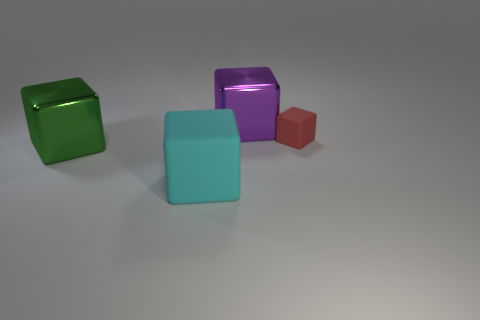Is there anything else that has the same size as the red object?
Your answer should be very brief. No. There is a metal cube that is in front of the red rubber object; is it the same size as the purple metal block?
Your answer should be very brief. Yes. There is a shiny thing behind the big metallic block that is in front of the red object; what number of large cyan rubber objects are behind it?
Your answer should be compact. 0. What size is the cube that is in front of the big purple thing and to the right of the cyan block?
Provide a succinct answer. Small. What number of other objects are the same shape as the purple metallic thing?
Offer a terse response. 3. What number of cubes are behind the cyan rubber cube?
Your response must be concise. 3. Are there fewer small red blocks in front of the big green metallic object than cyan matte blocks in front of the large purple block?
Provide a short and direct response. Yes. There is a rubber thing in front of the rubber object behind the rubber cube that is in front of the tiny red block; what shape is it?
Keep it short and to the point. Cube. Is there a tiny gray cube that has the same material as the small red object?
Give a very brief answer. No. What color is the shiny cube to the left of the big cyan cube?
Your answer should be very brief. Green. 